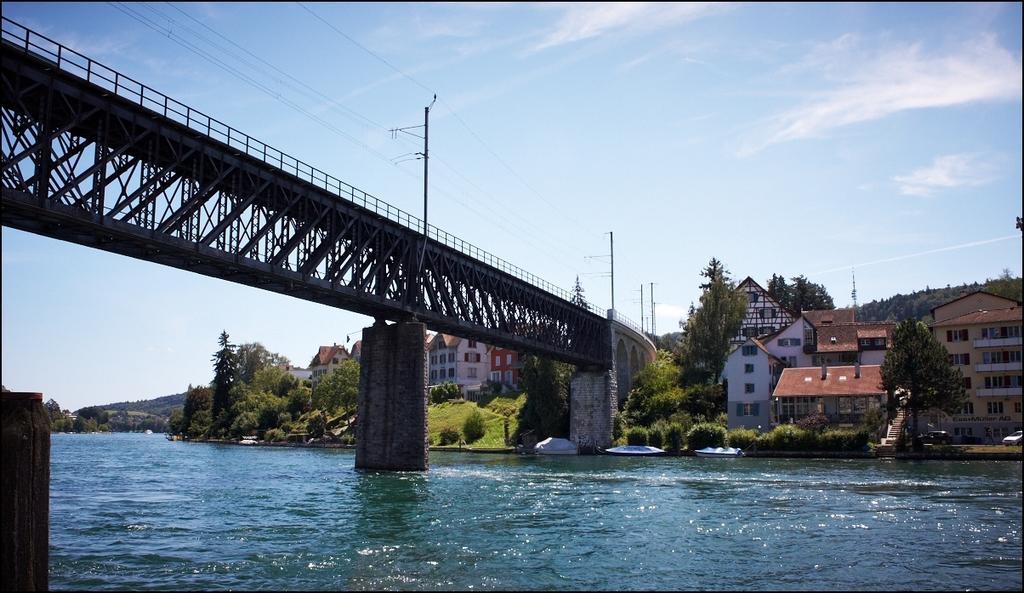How would you summarize this image in a sentence or two? This looks like a river with the water flowing. These are the trees and the bushes. I can see the buildings with the windows. I think these are the boats, which are on the water. This looks like a bridge, which is across the river. These are the pillars. These look like the current polls on the bridge. 